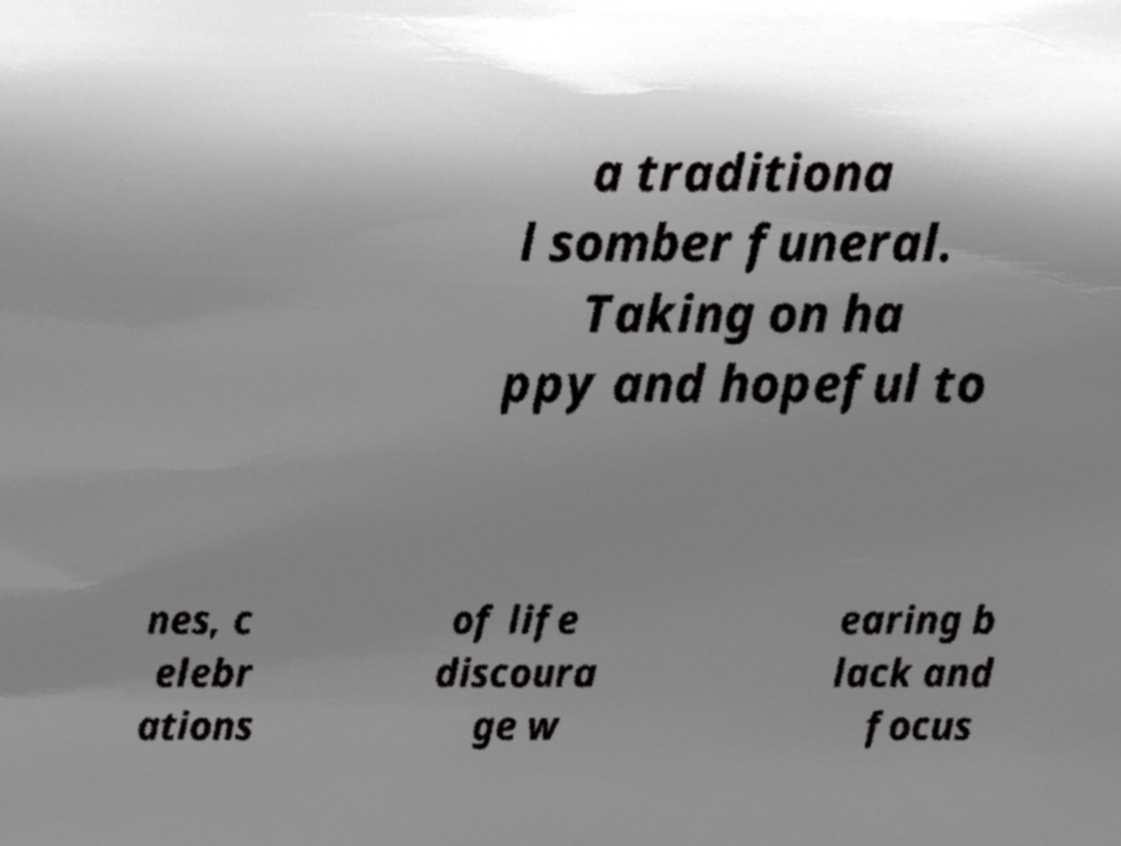Please read and relay the text visible in this image. What does it say? a traditiona l somber funeral. Taking on ha ppy and hopeful to nes, c elebr ations of life discoura ge w earing b lack and focus 